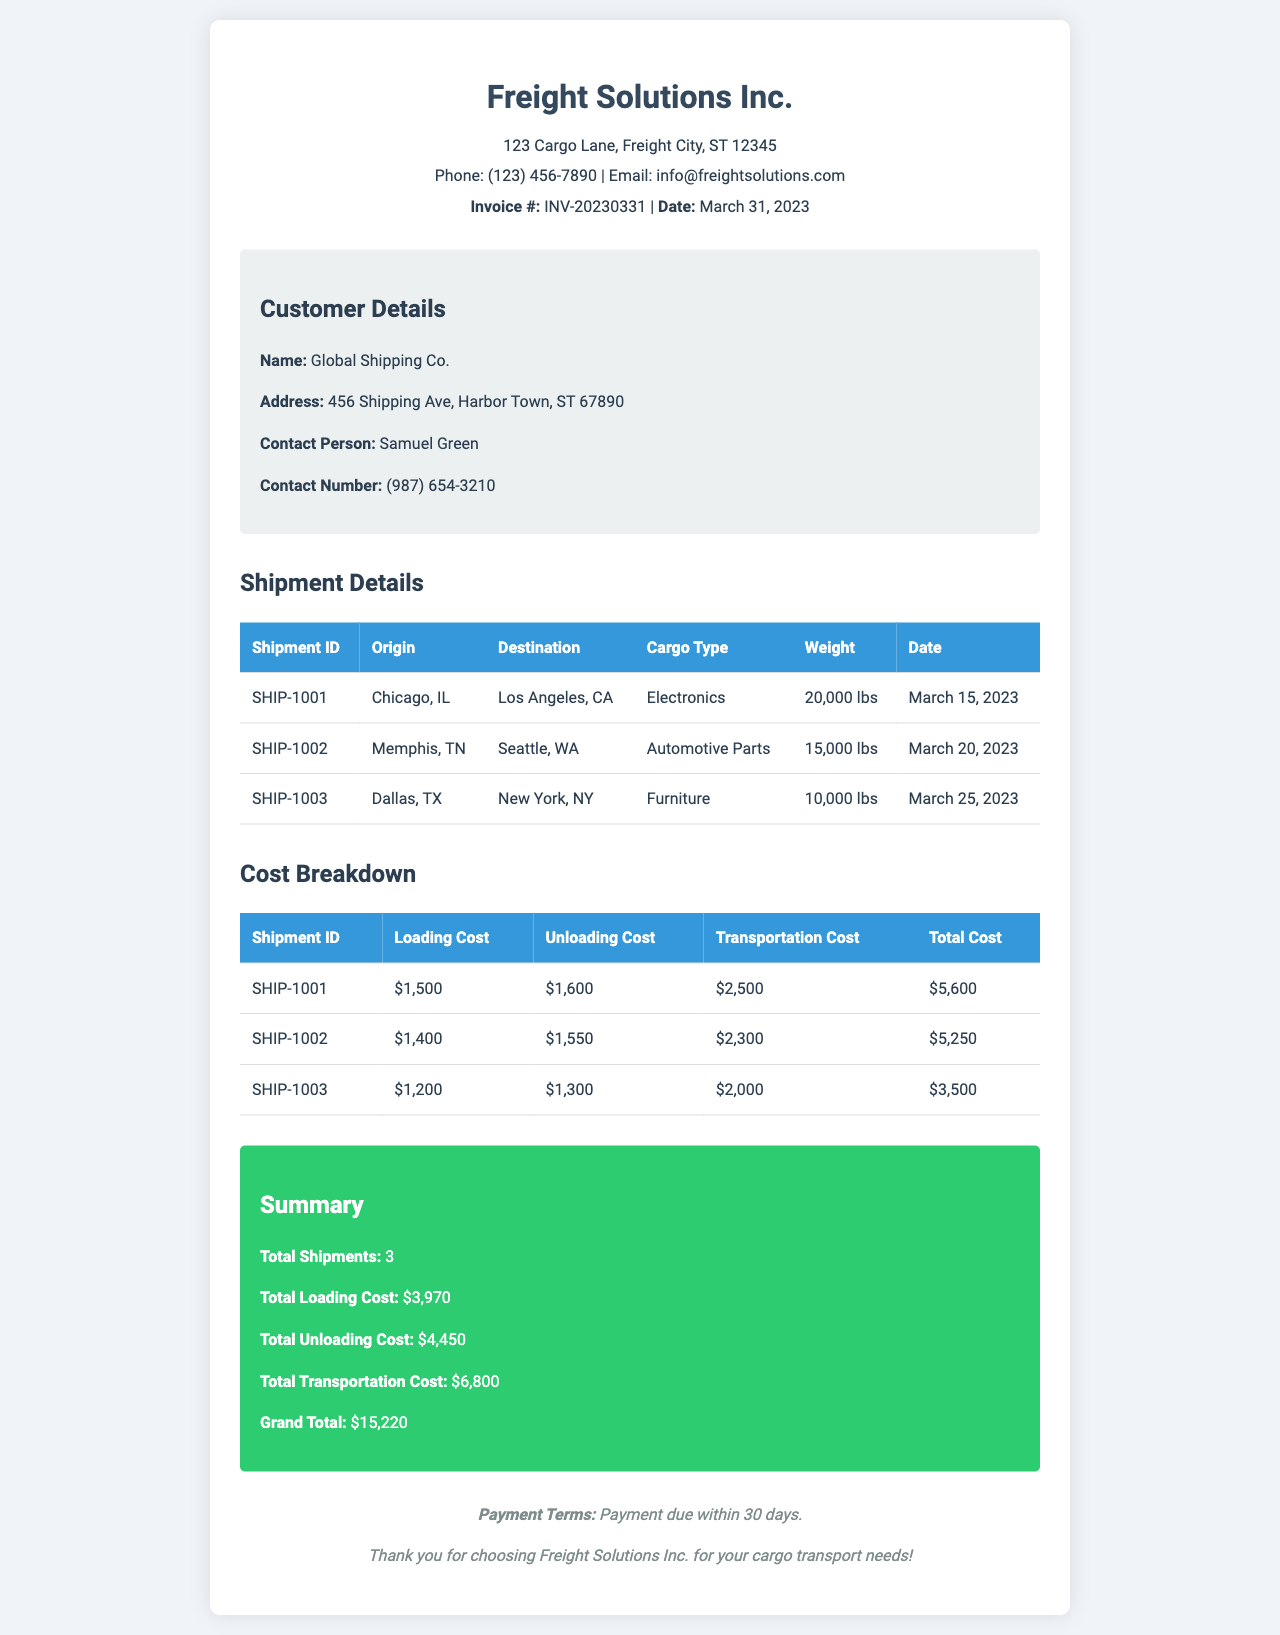What is the total cost for Shipment ID SHIP-1001? The total cost for Shipment ID SHIP-1001 is listed in the cost breakdown section as $5,600.
Answer: $5,600 Who is the contact person for Global Shipping Co.? The contact person for Global Shipping Co. is identified as Samuel Green in the customer details section.
Answer: Samuel Green What is the loading cost for Shipment ID SHIP-1002? The loading cost for Shipment ID SHIP-1002 is provided in the cost breakdown as $1,400.
Answer: $1,400 How many shipments are detailed in the document? The total number of shipments is summarized in the document under the summary section, which states there are 3 shipments.
Answer: 3 What is the grand total for all shipments? The grand total is the cumulative cost for all shipments, presented in the summary section as $15,220.
Answer: $15,220 What type of cargo was transported for Shipment ID SHIP-1003? The cargo type for Shipment ID SHIP-1003 is specified in the shipment details as Furniture.
Answer: Furniture What is the transportation cost for the shipment from Memphis, TN to Seattle, WA? The transportation cost for the shipment from Memphis, TN to Seattle, WA is listed in the cost breakdown as $2,300.
Answer: $2,300 Where is Freight Solutions Inc. located? The address of Freight Solutions Inc. is provided in the header as 123 Cargo Lane, Freight City, ST 12345.
Answer: 123 Cargo Lane, Freight City, ST 12345 What date was the invoice issued? The date of the invoice is mentioned in the header as March 31, 2023.
Answer: March 31, 2023 